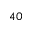<formula> <loc_0><loc_0><loc_500><loc_500>_ { 4 0 }</formula> 